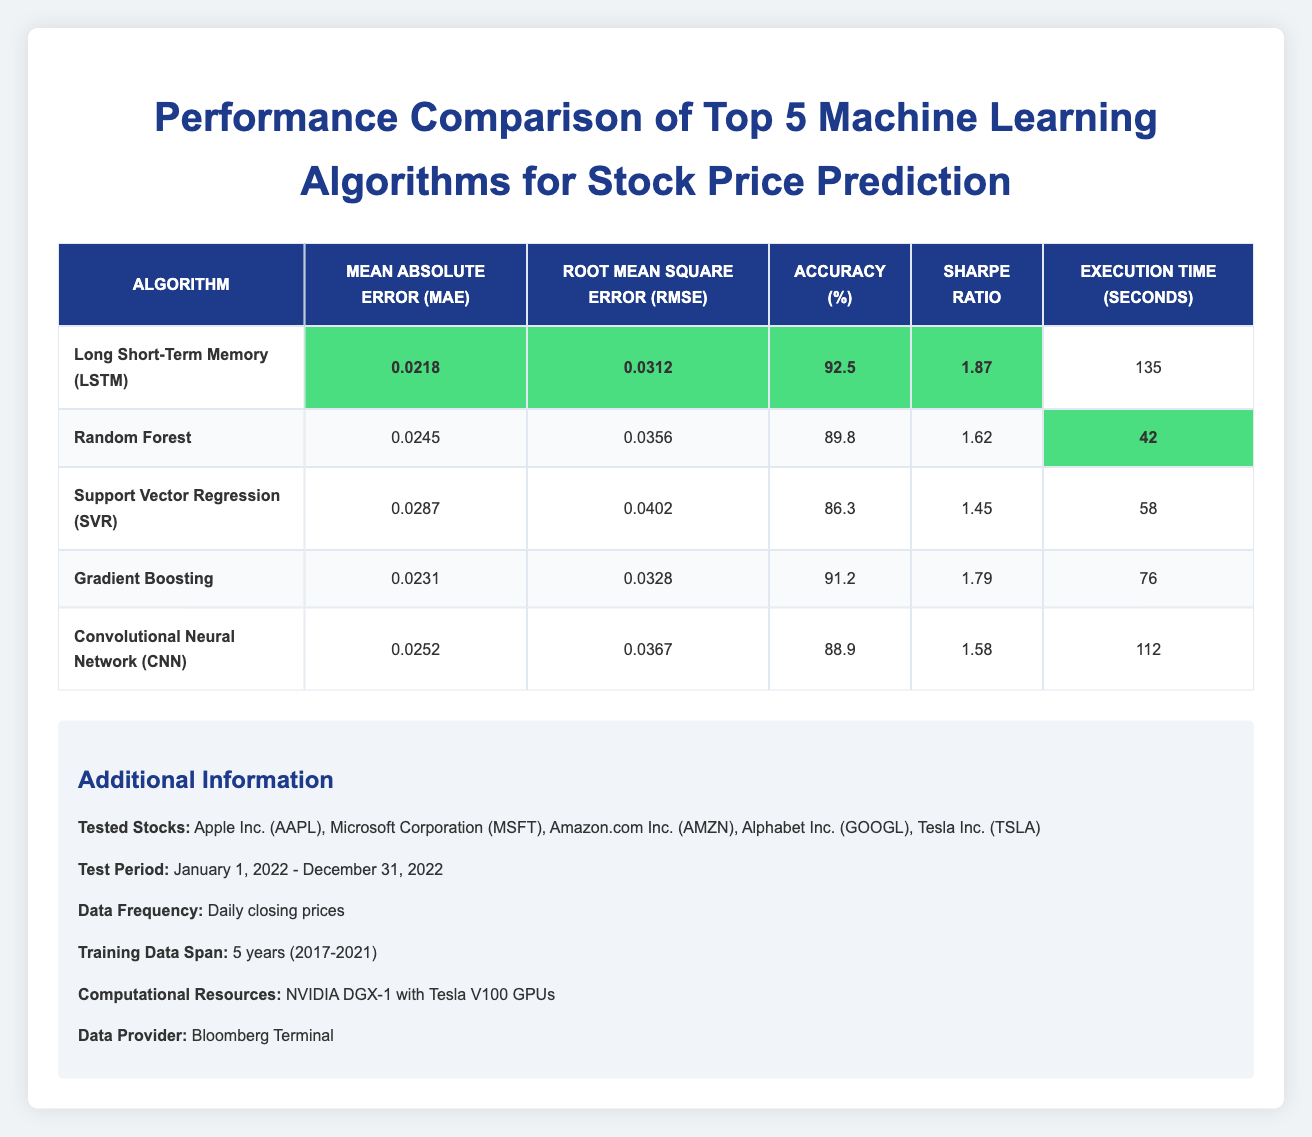What is the Mean Absolute Error (MAE) for the Long Short-Term Memory (LSTM) algorithm? Referring to the table, the row corresponding to the LSTM algorithm shows that the Mean Absolute Error (MAE) is listed as 0.0218.
Answer: 0.0218 Which algorithm has the highest accuracy? From the table, the accuracy values for all algorithms are compared. LSTM has an accuracy of 92.5%, which is higher than the other algorithms listed.
Answer: Long Short-Term Memory (LSTM) What is the difference in execution time between the Random Forest algorithm and the Convolutional Neural Network (CNN) algorithm? The execution time for Random Forest is 42 seconds and for CNN is 112 seconds. The difference is calculated by subtracting the execution time of Random Forest from that of CNN: 112 - 42 = 70 seconds.
Answer: 70 seconds Is the Sharpe Ratio for Support Vector Regression (SVR) greater than 1.5? Looking at the table, the Sharpe Ratio for SVR is 1.45, which is less than 1.5. Therefore, the answer is no.
Answer: No What is the average Mean Absolute Error (MAE) for all the algorithms listed? To find the average MAE, we sum all the MAE values: 0.0218 + 0.0245 + 0.0287 + 0.0231 + 0.0252 = 0.1233. There are 5 algorithms, so the average MAE is calculated as 0.1233 / 5 = 0.02466.
Answer: 0.02466 Which algorithm has the second-lowest Root Mean Square Error (RMSE)? The RMSE values for each algorithm are compared. LSTM has the lowest RMSE (0.0312), and Gradient Boosting has the second-lowest RMSE at 0.0328, as it is higher than that of Random Forest and SVR.
Answer: Gradient Boosting Does the Convolutional Neural Network (CNN) algorithm have the highest Sharpe Ratio among the listed algorithms? From the table, CNN has a Sharpe Ratio of 1.58, which is lower than the LSTM's Sharpe Ratio of 1.87. Therefore, CNN does not have the highest Sharpe Ratio.
Answer: No What is the total execution time for all algorithms combined? To find the total execution time, sum the individual execution times: 135 + 42 + 58 + 76 + 112 = 423 seconds.
Answer: 423 seconds 